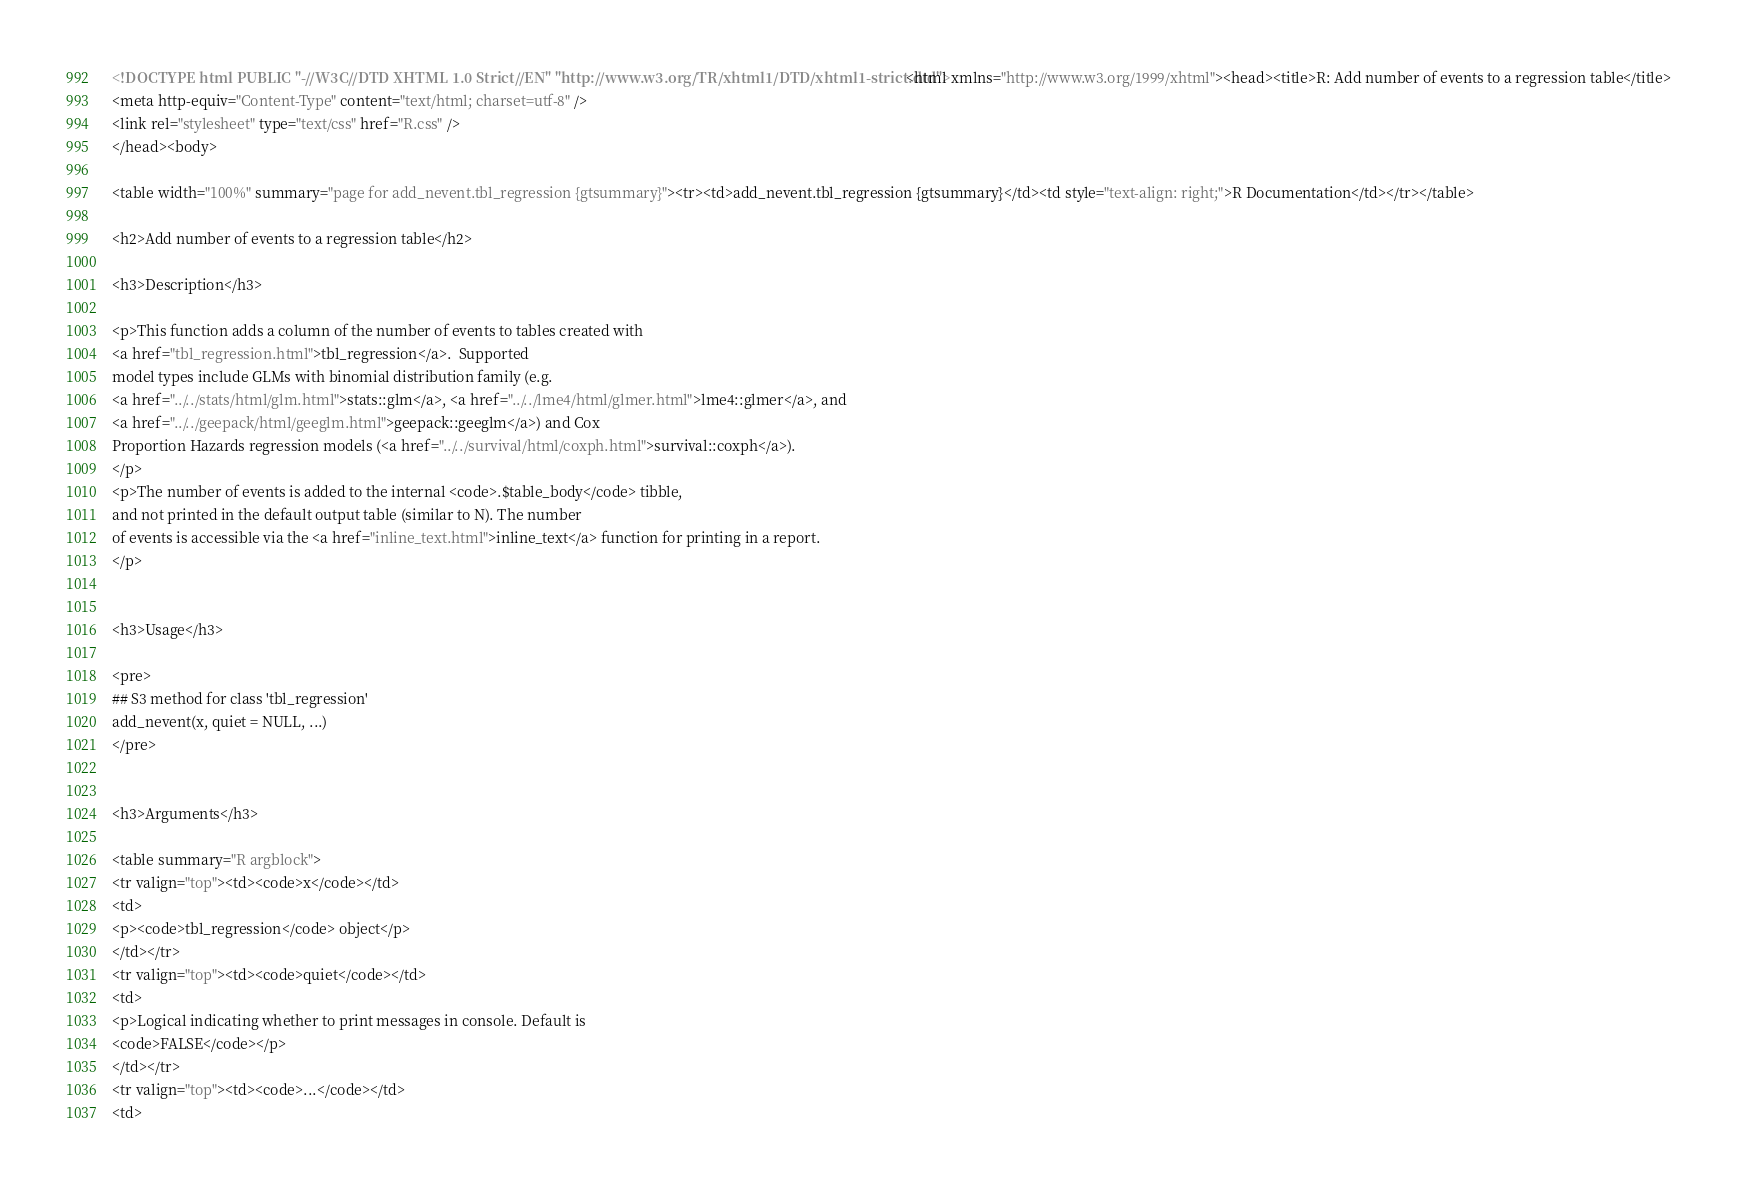<code> <loc_0><loc_0><loc_500><loc_500><_HTML_><!DOCTYPE html PUBLIC "-//W3C//DTD XHTML 1.0 Strict//EN" "http://www.w3.org/TR/xhtml1/DTD/xhtml1-strict.dtd"><html xmlns="http://www.w3.org/1999/xhtml"><head><title>R: Add number of events to a regression table</title>
<meta http-equiv="Content-Type" content="text/html; charset=utf-8" />
<link rel="stylesheet" type="text/css" href="R.css" />
</head><body>

<table width="100%" summary="page for add_nevent.tbl_regression {gtsummary}"><tr><td>add_nevent.tbl_regression {gtsummary}</td><td style="text-align: right;">R Documentation</td></tr></table>

<h2>Add number of events to a regression table</h2>

<h3>Description</h3>

<p>This function adds a column of the number of events to tables created with
<a href="tbl_regression.html">tbl_regression</a>.  Supported
model types include GLMs with binomial distribution family (e.g.
<a href="../../stats/html/glm.html">stats::glm</a>, <a href="../../lme4/html/glmer.html">lme4::glmer</a>, and
<a href="../../geepack/html/geeglm.html">geepack::geeglm</a>) and Cox
Proportion Hazards regression models (<a href="../../survival/html/coxph.html">survival::coxph</a>).
</p>
<p>The number of events is added to the internal <code>.$table_body</code> tibble,
and not printed in the default output table (similar to N). The number
of events is accessible via the <a href="inline_text.html">inline_text</a> function for printing in a report.
</p>


<h3>Usage</h3>

<pre>
## S3 method for class 'tbl_regression'
add_nevent(x, quiet = NULL, ...)
</pre>


<h3>Arguments</h3>

<table summary="R argblock">
<tr valign="top"><td><code>x</code></td>
<td>
<p><code>tbl_regression</code> object</p>
</td></tr>
<tr valign="top"><td><code>quiet</code></td>
<td>
<p>Logical indicating whether to print messages in console. Default is
<code>FALSE</code></p>
</td></tr>
<tr valign="top"><td><code>...</code></td>
<td></code> 